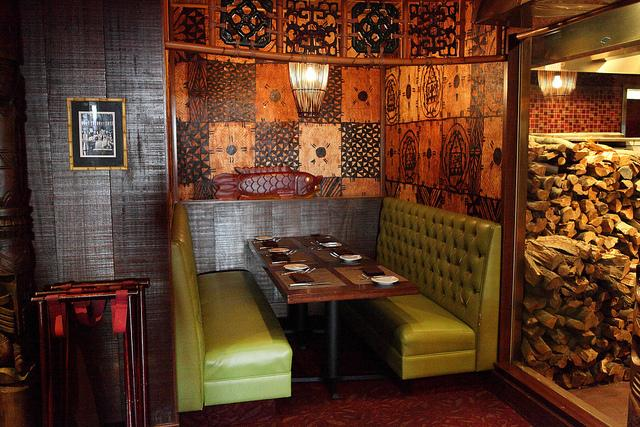How many people could fit comfortably in each booth? four 